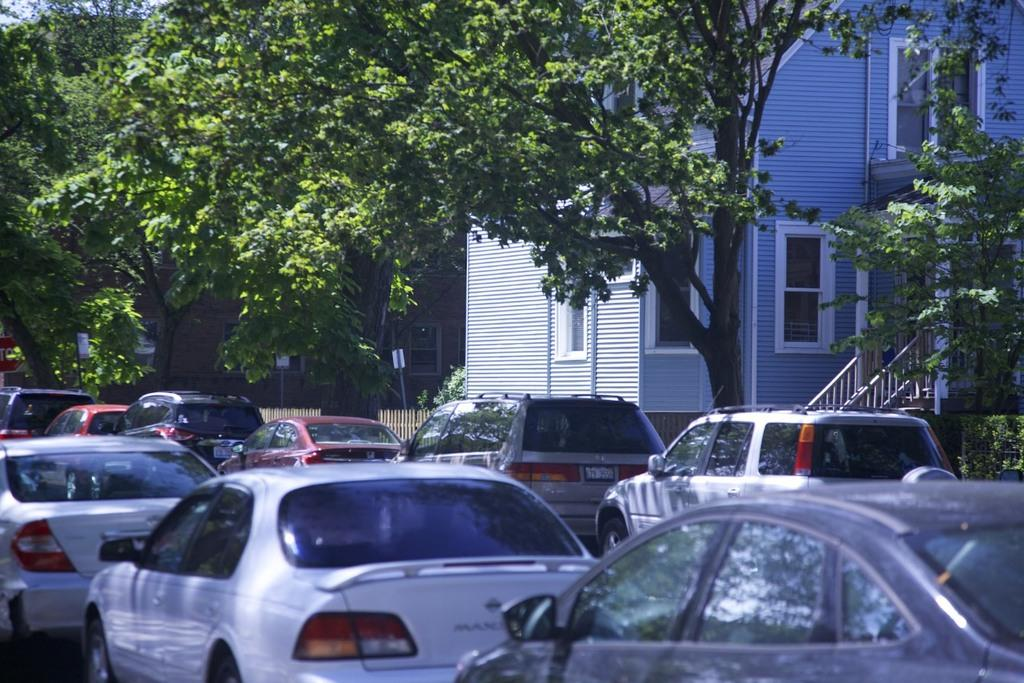What can be seen on the road in the image? There are many cars on the road in the image. What type of vegetation is present beside the cars? There are trees, plants, and hedges beside the cars. What is visible behind the cars in the image? There are buildings behind the cars. Can you see a swing in the image? No, there is no swing present in the image. Are there any tomatoes growing on the plants beside the cars? The image does not provide information about the type of plants beside the cars, so it cannot be determined if tomatoes are growing on them. 